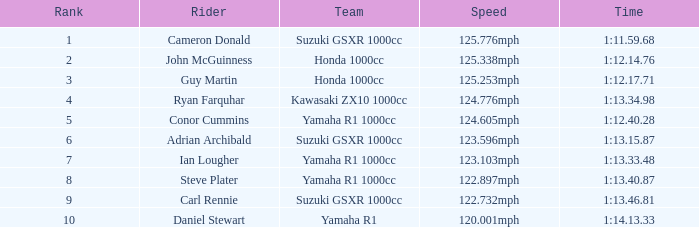What is the placement for the team with a time of 1:1 5.0. 